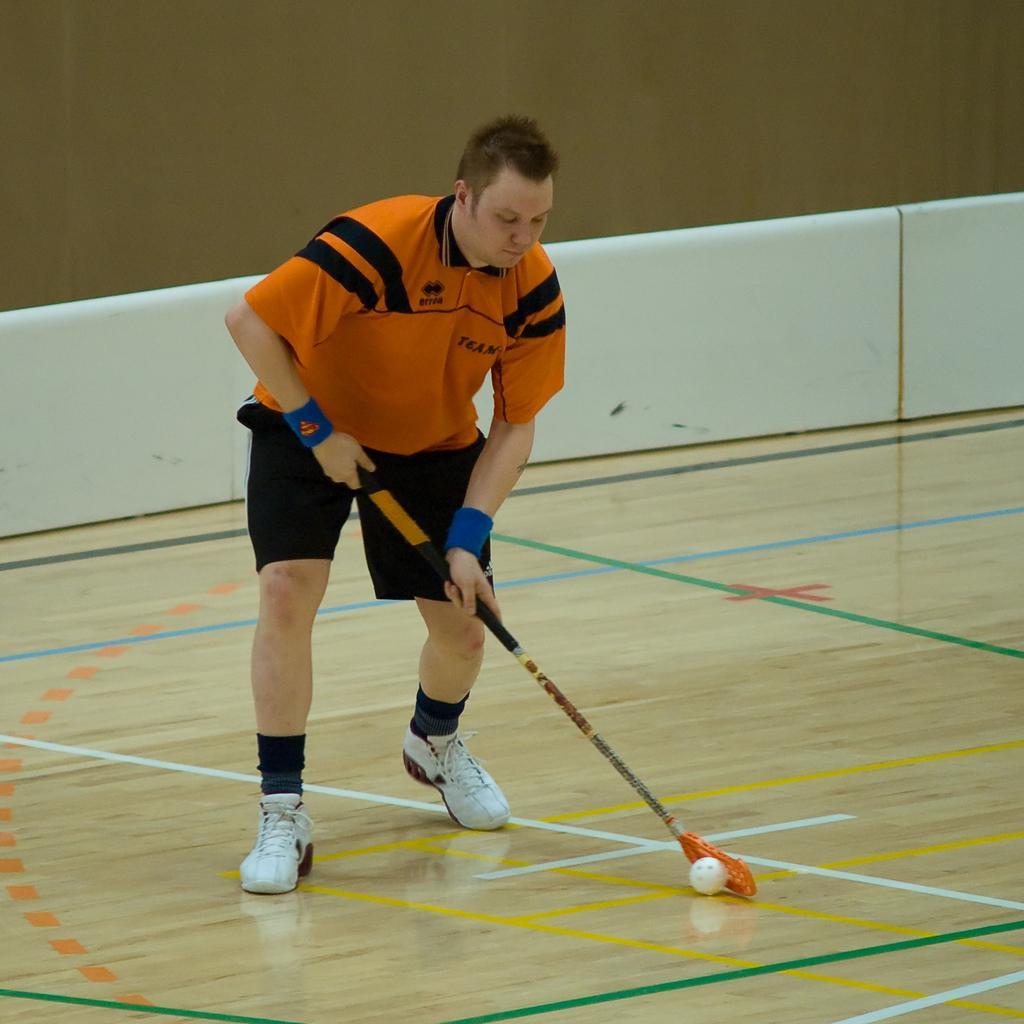Could you give a brief overview of what you see in this image? In this image we can see a layer on the floor and he is holding a floor ball stick. We can also see a plastic ball. In the background there is wall and also the white color barrier. 